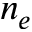Convert formula to latex. <formula><loc_0><loc_0><loc_500><loc_500>n _ { e }</formula> 